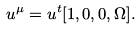Convert formula to latex. <formula><loc_0><loc_0><loc_500><loc_500>u ^ { \mu } = u ^ { t } [ 1 , 0 , 0 , \Omega ] .</formula> 